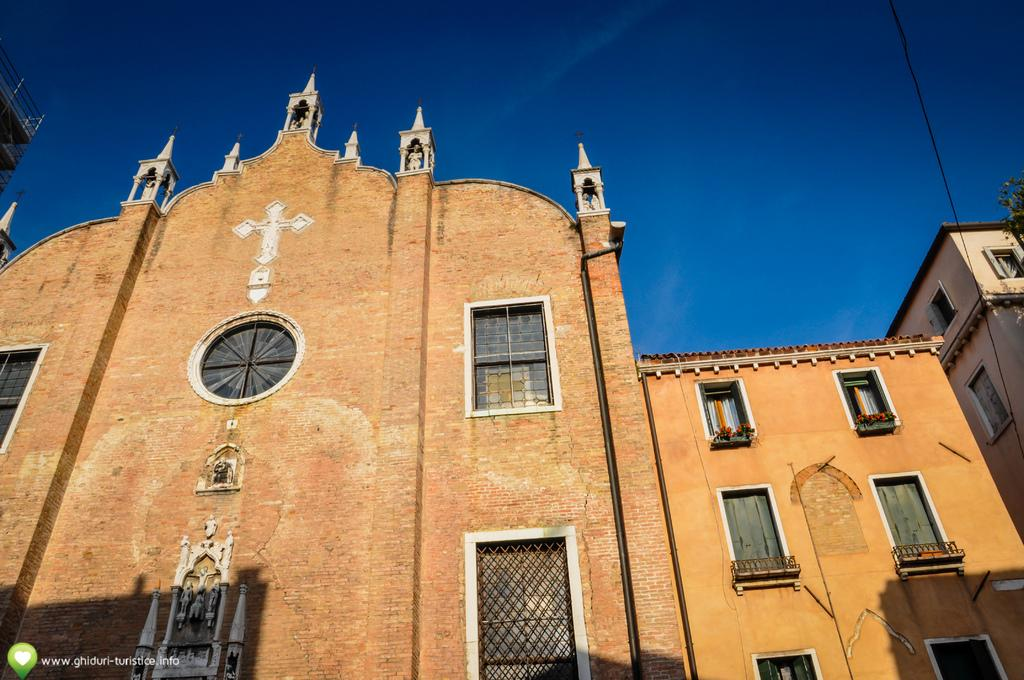What type of structures are visible in the image? There are buildings in the image. What architectural feature can be seen on the buildings? There are windows on the wall in the image. Are there any additional elements on the wall? Yes, there are symbols on the wall in the image. Can you tell me how many cars are parked in front of the buildings in the image? There is no information about cars in the image; it only mentions buildings, windows, and symbols on the wall. Are there any toys visible in the image? There is no mention of toys in the image. 